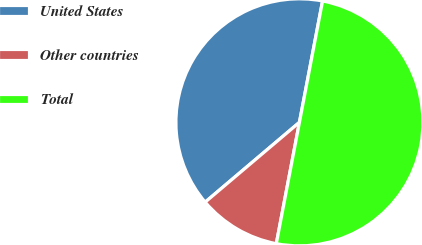<chart> <loc_0><loc_0><loc_500><loc_500><pie_chart><fcel>United States<fcel>Other countries<fcel>Total<nl><fcel>39.18%<fcel>10.82%<fcel>50.0%<nl></chart> 